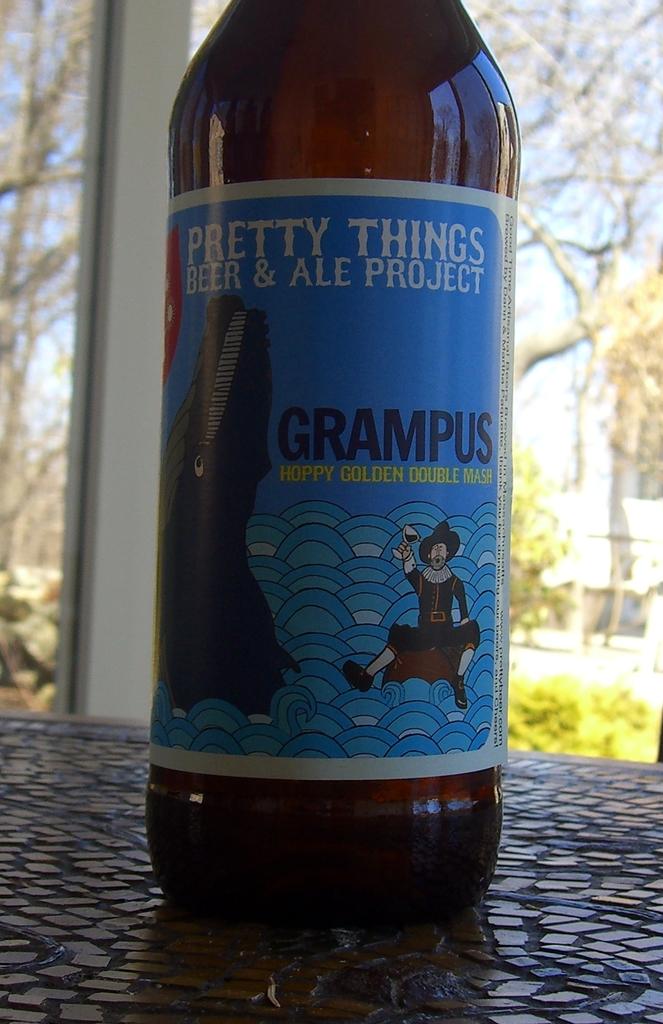What brand is this?
Offer a very short reply. Pretty things. 